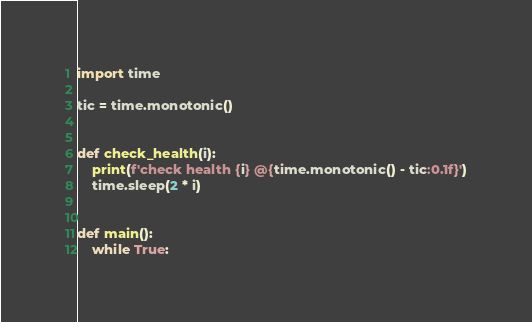<code> <loc_0><loc_0><loc_500><loc_500><_Python_>import time

tic = time.monotonic()


def check_health(i):
    print(f'check health {i} @{time.monotonic() - tic:0.1f}')
    time.sleep(2 * i)


def main():
    while True:</code> 